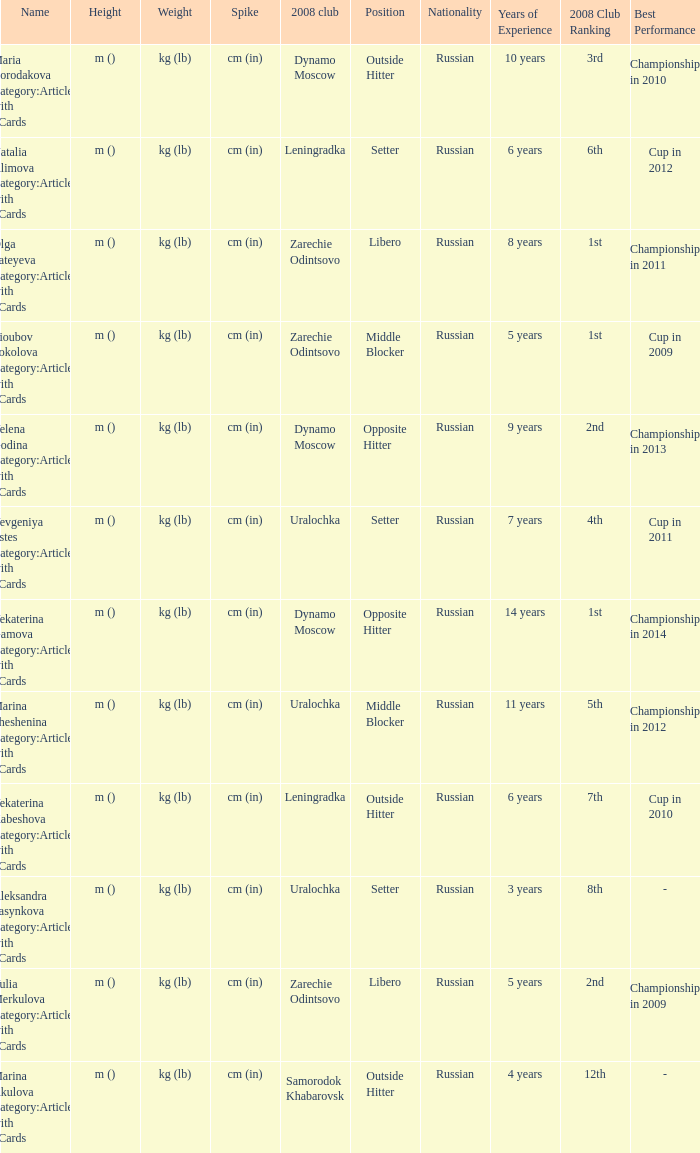What is the name of the club known as zarechie odintsovo in 2008? Olga Fateyeva Category:Articles with hCards, Lioubov Sokolova Category:Articles with hCards, Yulia Merkulova Category:Articles with hCards. 